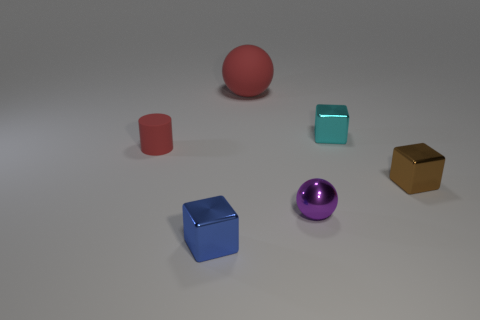Are there the same number of purple metal balls in front of the metal ball and big spheres?
Provide a succinct answer. No. Is there a purple shiny object in front of the small thing left of the cube that is left of the big red sphere?
Your answer should be very brief. Yes. What is the material of the blue thing?
Your response must be concise. Metal. How many other objects are there of the same shape as the purple metal thing?
Offer a very short reply. 1. Do the brown metal thing and the blue object have the same shape?
Offer a terse response. Yes. What number of things are metal balls in front of the matte cylinder or tiny objects behind the tiny brown object?
Keep it short and to the point. 3. What number of things are either small blue matte balls or purple metal things?
Give a very brief answer. 1. How many small cubes are right of the red rubber ball that is behind the brown block?
Offer a terse response. 2. How many other objects are there of the same size as the brown block?
Offer a terse response. 4. The thing that is the same color as the big matte sphere is what size?
Offer a very short reply. Small. 